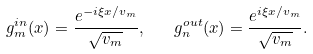Convert formula to latex. <formula><loc_0><loc_0><loc_500><loc_500>g ^ { i n } _ { m } ( x ) = \frac { e ^ { - i \xi x / v _ { m } } } { \sqrt { v _ { m } } } , \quad g ^ { o u t } _ { n } ( x ) = \frac { e ^ { i \xi x / v _ { m } } } { \sqrt { v _ { m } } } .</formula> 